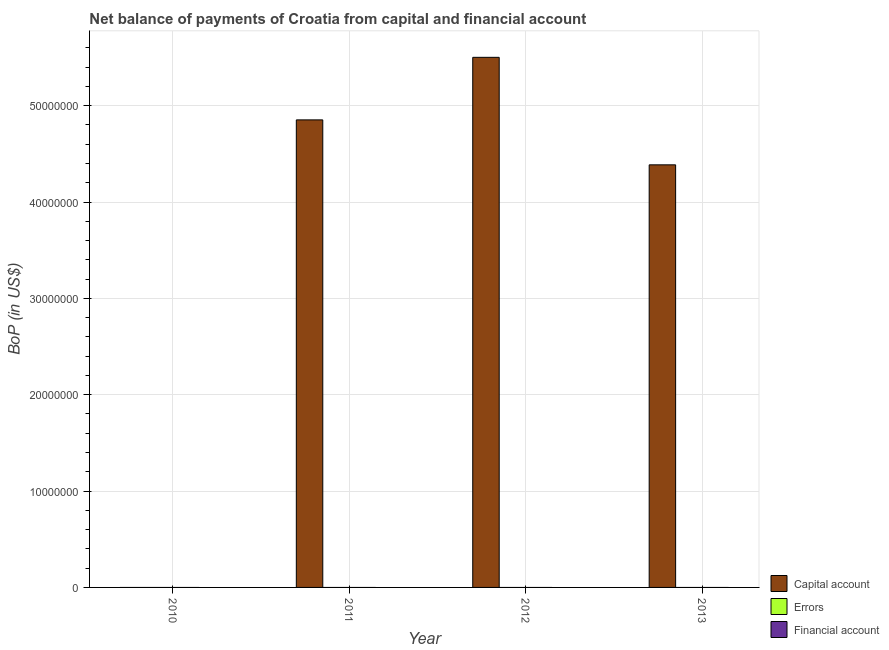How many different coloured bars are there?
Keep it short and to the point. 1. How many bars are there on the 1st tick from the left?
Ensure brevity in your answer.  0. How many bars are there on the 2nd tick from the right?
Provide a succinct answer. 1. Across all years, what is the maximum amount of net capital account?
Your answer should be very brief. 5.50e+07. What is the total amount of errors in the graph?
Offer a very short reply. 0. What is the difference between the amount of net capital account in 2012 and that in 2013?
Ensure brevity in your answer.  1.12e+07. What is the average amount of net capital account per year?
Provide a succinct answer. 3.68e+07. In how many years, is the amount of errors greater than 6000000 US$?
Your answer should be compact. 0. What is the difference between the highest and the second highest amount of net capital account?
Your answer should be very brief. 6.49e+06. What is the difference between the highest and the lowest amount of net capital account?
Offer a terse response. 5.50e+07. In how many years, is the amount of financial account greater than the average amount of financial account taken over all years?
Offer a terse response. 0. How many bars are there?
Provide a succinct answer. 3. How many years are there in the graph?
Provide a succinct answer. 4. Does the graph contain any zero values?
Provide a succinct answer. Yes. Does the graph contain grids?
Provide a succinct answer. Yes. How many legend labels are there?
Provide a succinct answer. 3. How are the legend labels stacked?
Keep it short and to the point. Vertical. What is the title of the graph?
Offer a very short reply. Net balance of payments of Croatia from capital and financial account. What is the label or title of the X-axis?
Make the answer very short. Year. What is the label or title of the Y-axis?
Your answer should be very brief. BoP (in US$). What is the BoP (in US$) of Errors in 2010?
Keep it short and to the point. 0. What is the BoP (in US$) of Capital account in 2011?
Your response must be concise. 4.85e+07. What is the BoP (in US$) in Errors in 2011?
Provide a succinct answer. 0. What is the BoP (in US$) in Financial account in 2011?
Ensure brevity in your answer.  0. What is the BoP (in US$) of Capital account in 2012?
Offer a very short reply. 5.50e+07. What is the BoP (in US$) in Capital account in 2013?
Your response must be concise. 4.39e+07. What is the BoP (in US$) in Errors in 2013?
Provide a short and direct response. 0. Across all years, what is the maximum BoP (in US$) of Capital account?
Your response must be concise. 5.50e+07. What is the total BoP (in US$) in Capital account in the graph?
Provide a short and direct response. 1.47e+08. What is the total BoP (in US$) of Financial account in the graph?
Provide a succinct answer. 0. What is the difference between the BoP (in US$) of Capital account in 2011 and that in 2012?
Provide a short and direct response. -6.49e+06. What is the difference between the BoP (in US$) in Capital account in 2011 and that in 2013?
Your answer should be compact. 4.67e+06. What is the difference between the BoP (in US$) in Capital account in 2012 and that in 2013?
Offer a very short reply. 1.12e+07. What is the average BoP (in US$) of Capital account per year?
Ensure brevity in your answer.  3.68e+07. What is the average BoP (in US$) of Financial account per year?
Provide a succinct answer. 0. What is the ratio of the BoP (in US$) in Capital account in 2011 to that in 2012?
Your answer should be compact. 0.88. What is the ratio of the BoP (in US$) in Capital account in 2011 to that in 2013?
Your response must be concise. 1.11. What is the ratio of the BoP (in US$) of Capital account in 2012 to that in 2013?
Ensure brevity in your answer.  1.25. What is the difference between the highest and the second highest BoP (in US$) of Capital account?
Provide a short and direct response. 6.49e+06. What is the difference between the highest and the lowest BoP (in US$) of Capital account?
Ensure brevity in your answer.  5.50e+07. 